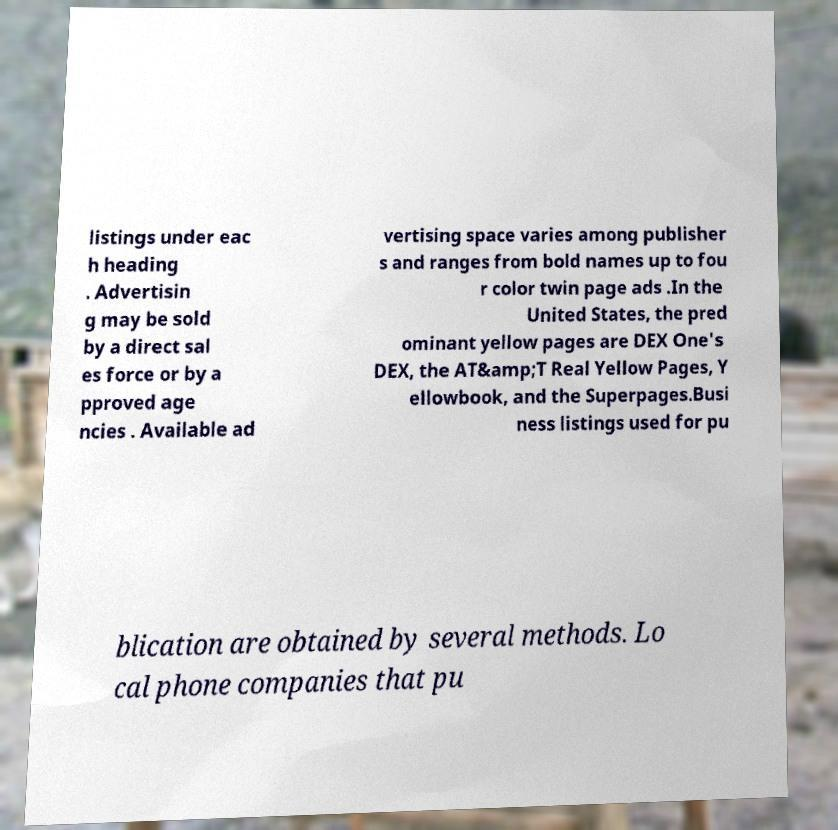Could you extract and type out the text from this image? listings under eac h heading . Advertisin g may be sold by a direct sal es force or by a pproved age ncies . Available ad vertising space varies among publisher s and ranges from bold names up to fou r color twin page ads .In the United States, the pred ominant yellow pages are DEX One's DEX, the AT&amp;T Real Yellow Pages, Y ellowbook, and the Superpages.Busi ness listings used for pu blication are obtained by several methods. Lo cal phone companies that pu 